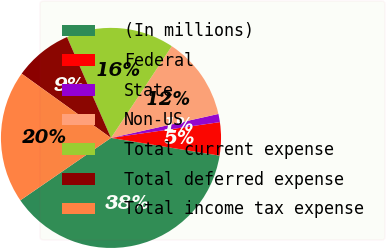Convert chart. <chart><loc_0><loc_0><loc_500><loc_500><pie_chart><fcel>(In millions)<fcel>Federal<fcel>State<fcel>Non-US<fcel>Total current expense<fcel>Total deferred expense<fcel>Total income tax expense<nl><fcel>37.83%<fcel>4.87%<fcel>1.2%<fcel>12.19%<fcel>15.86%<fcel>8.53%<fcel>19.52%<nl></chart> 